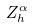Convert formula to latex. <formula><loc_0><loc_0><loc_500><loc_500>Z _ { h } ^ { \alpha }</formula> 